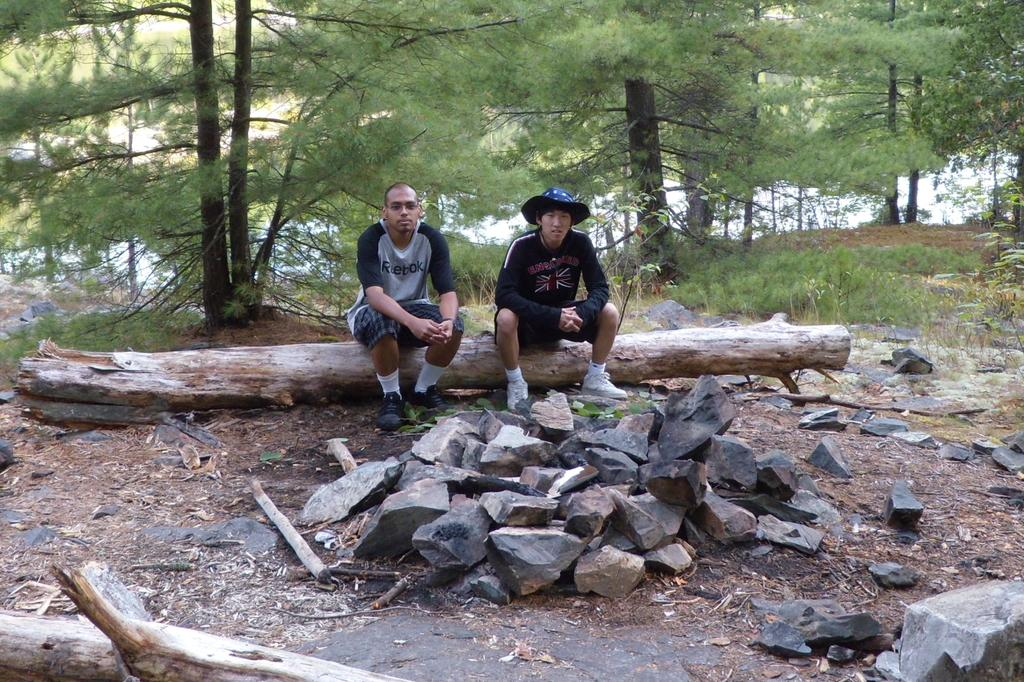How many people are sitting on the wooden log in the image? There are two persons sitting on a wooden log in the image. What else can be seen in the image besides the wooden log and the people? Stones are visible in the image. What is visible in the background of the image? There are trees in the background of the image. What is the color of the trees in the image? The trees are green in color. What is the weight of the basin in the image? There is no basin present in the image, so it is not possible to determine its weight. 